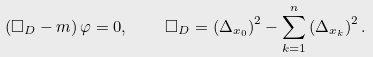Convert formula to latex. <formula><loc_0><loc_0><loc_500><loc_500>\left ( \Box _ { D } - m \right ) \varphi = 0 , \quad \square _ { D } = \left ( \Delta _ { x _ { 0 } } \right ) ^ { 2 } - \sum _ { k = 1 } ^ { n } \left ( \Delta _ { x _ { k } } \right ) ^ { 2 } .</formula> 